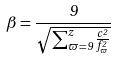<formula> <loc_0><loc_0><loc_500><loc_500>\beta = \frac { 9 } { \sqrt { \sum _ { \varpi = 9 } ^ { z } \frac { c ^ { 2 } } { f _ { \varpi } ^ { 2 } } } }</formula> 